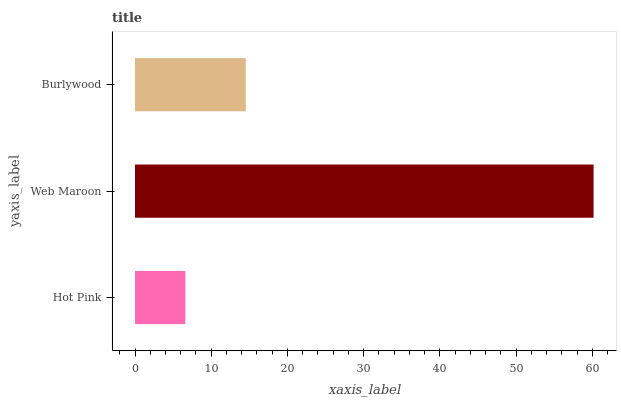Is Hot Pink the minimum?
Answer yes or no. Yes. Is Web Maroon the maximum?
Answer yes or no. Yes. Is Burlywood the minimum?
Answer yes or no. No. Is Burlywood the maximum?
Answer yes or no. No. Is Web Maroon greater than Burlywood?
Answer yes or no. Yes. Is Burlywood less than Web Maroon?
Answer yes or no. Yes. Is Burlywood greater than Web Maroon?
Answer yes or no. No. Is Web Maroon less than Burlywood?
Answer yes or no. No. Is Burlywood the high median?
Answer yes or no. Yes. Is Burlywood the low median?
Answer yes or no. Yes. Is Web Maroon the high median?
Answer yes or no. No. Is Web Maroon the low median?
Answer yes or no. No. 